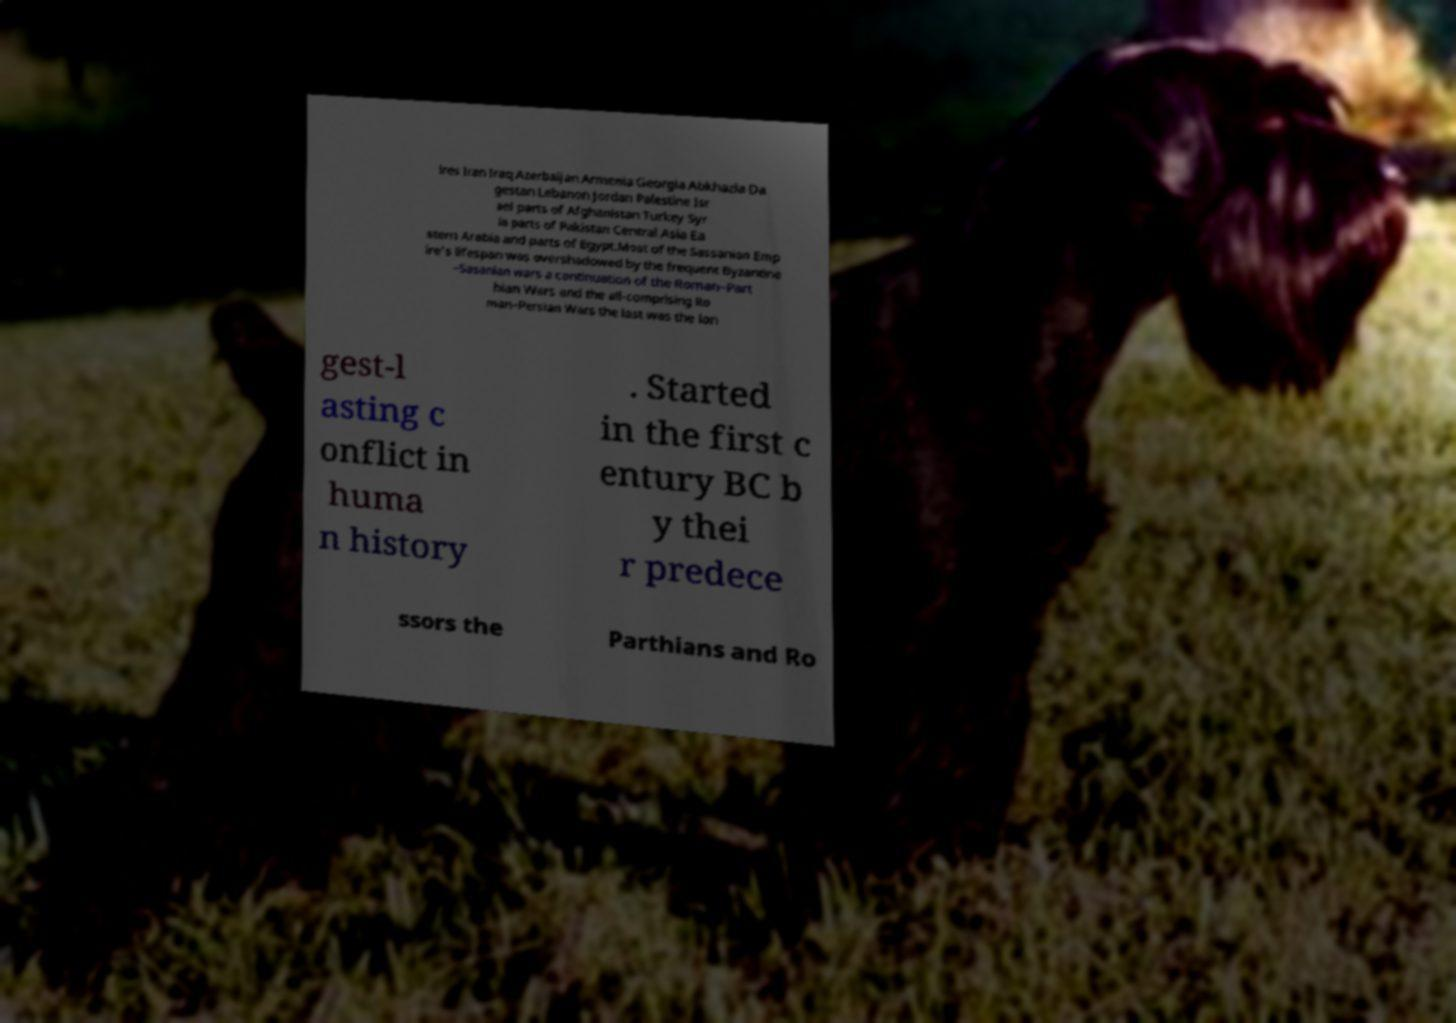Please read and relay the text visible in this image. What does it say? ires Iran Iraq Azerbaijan Armenia Georgia Abkhazia Da gestan Lebanon Jordan Palestine Isr ael parts of Afghanistan Turkey Syr ia parts of Pakistan Central Asia Ea stern Arabia and parts of Egypt.Most of the Sassanian Emp ire's lifespan was overshadowed by the frequent Byzantine –Sasanian wars a continuation of the Roman–Part hian Wars and the all-comprising Ro man–Persian Wars the last was the lon gest-l asting c onflict in huma n history . Started in the first c entury BC b y thei r predece ssors the Parthians and Ro 